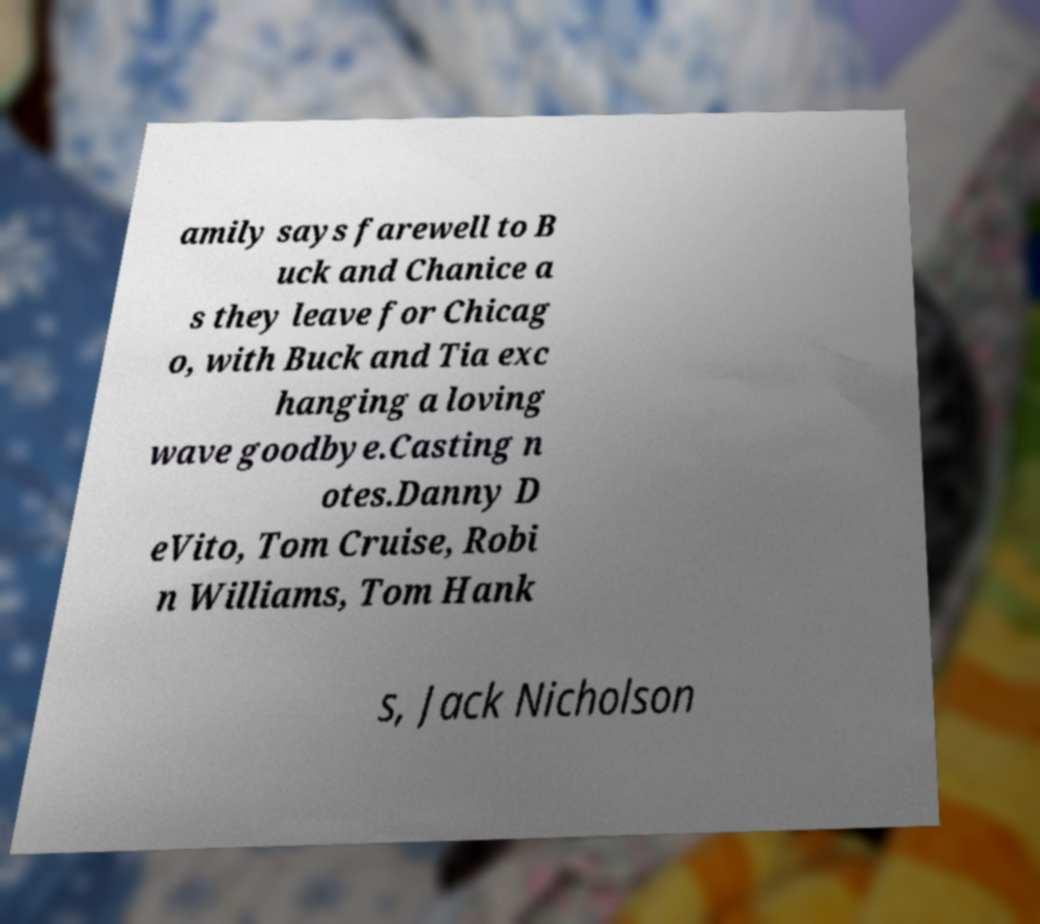Can you accurately transcribe the text from the provided image for me? amily says farewell to B uck and Chanice a s they leave for Chicag o, with Buck and Tia exc hanging a loving wave goodbye.Casting n otes.Danny D eVito, Tom Cruise, Robi n Williams, Tom Hank s, Jack Nicholson 